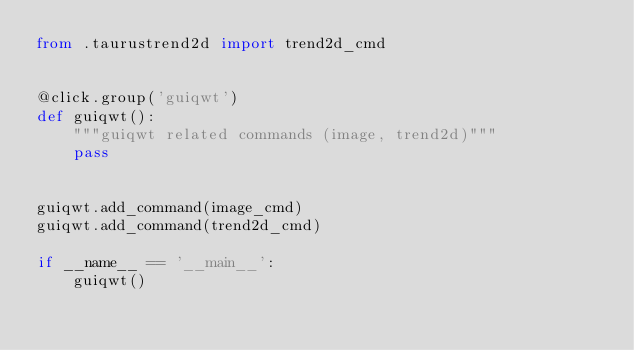Convert code to text. <code><loc_0><loc_0><loc_500><loc_500><_Python_>from .taurustrend2d import trend2d_cmd


@click.group('guiqwt')
def guiqwt():
    """guiqwt related commands (image, trend2d)"""
    pass


guiqwt.add_command(image_cmd)
guiqwt.add_command(trend2d_cmd)

if __name__ == '__main__':
    guiqwt()

</code> 